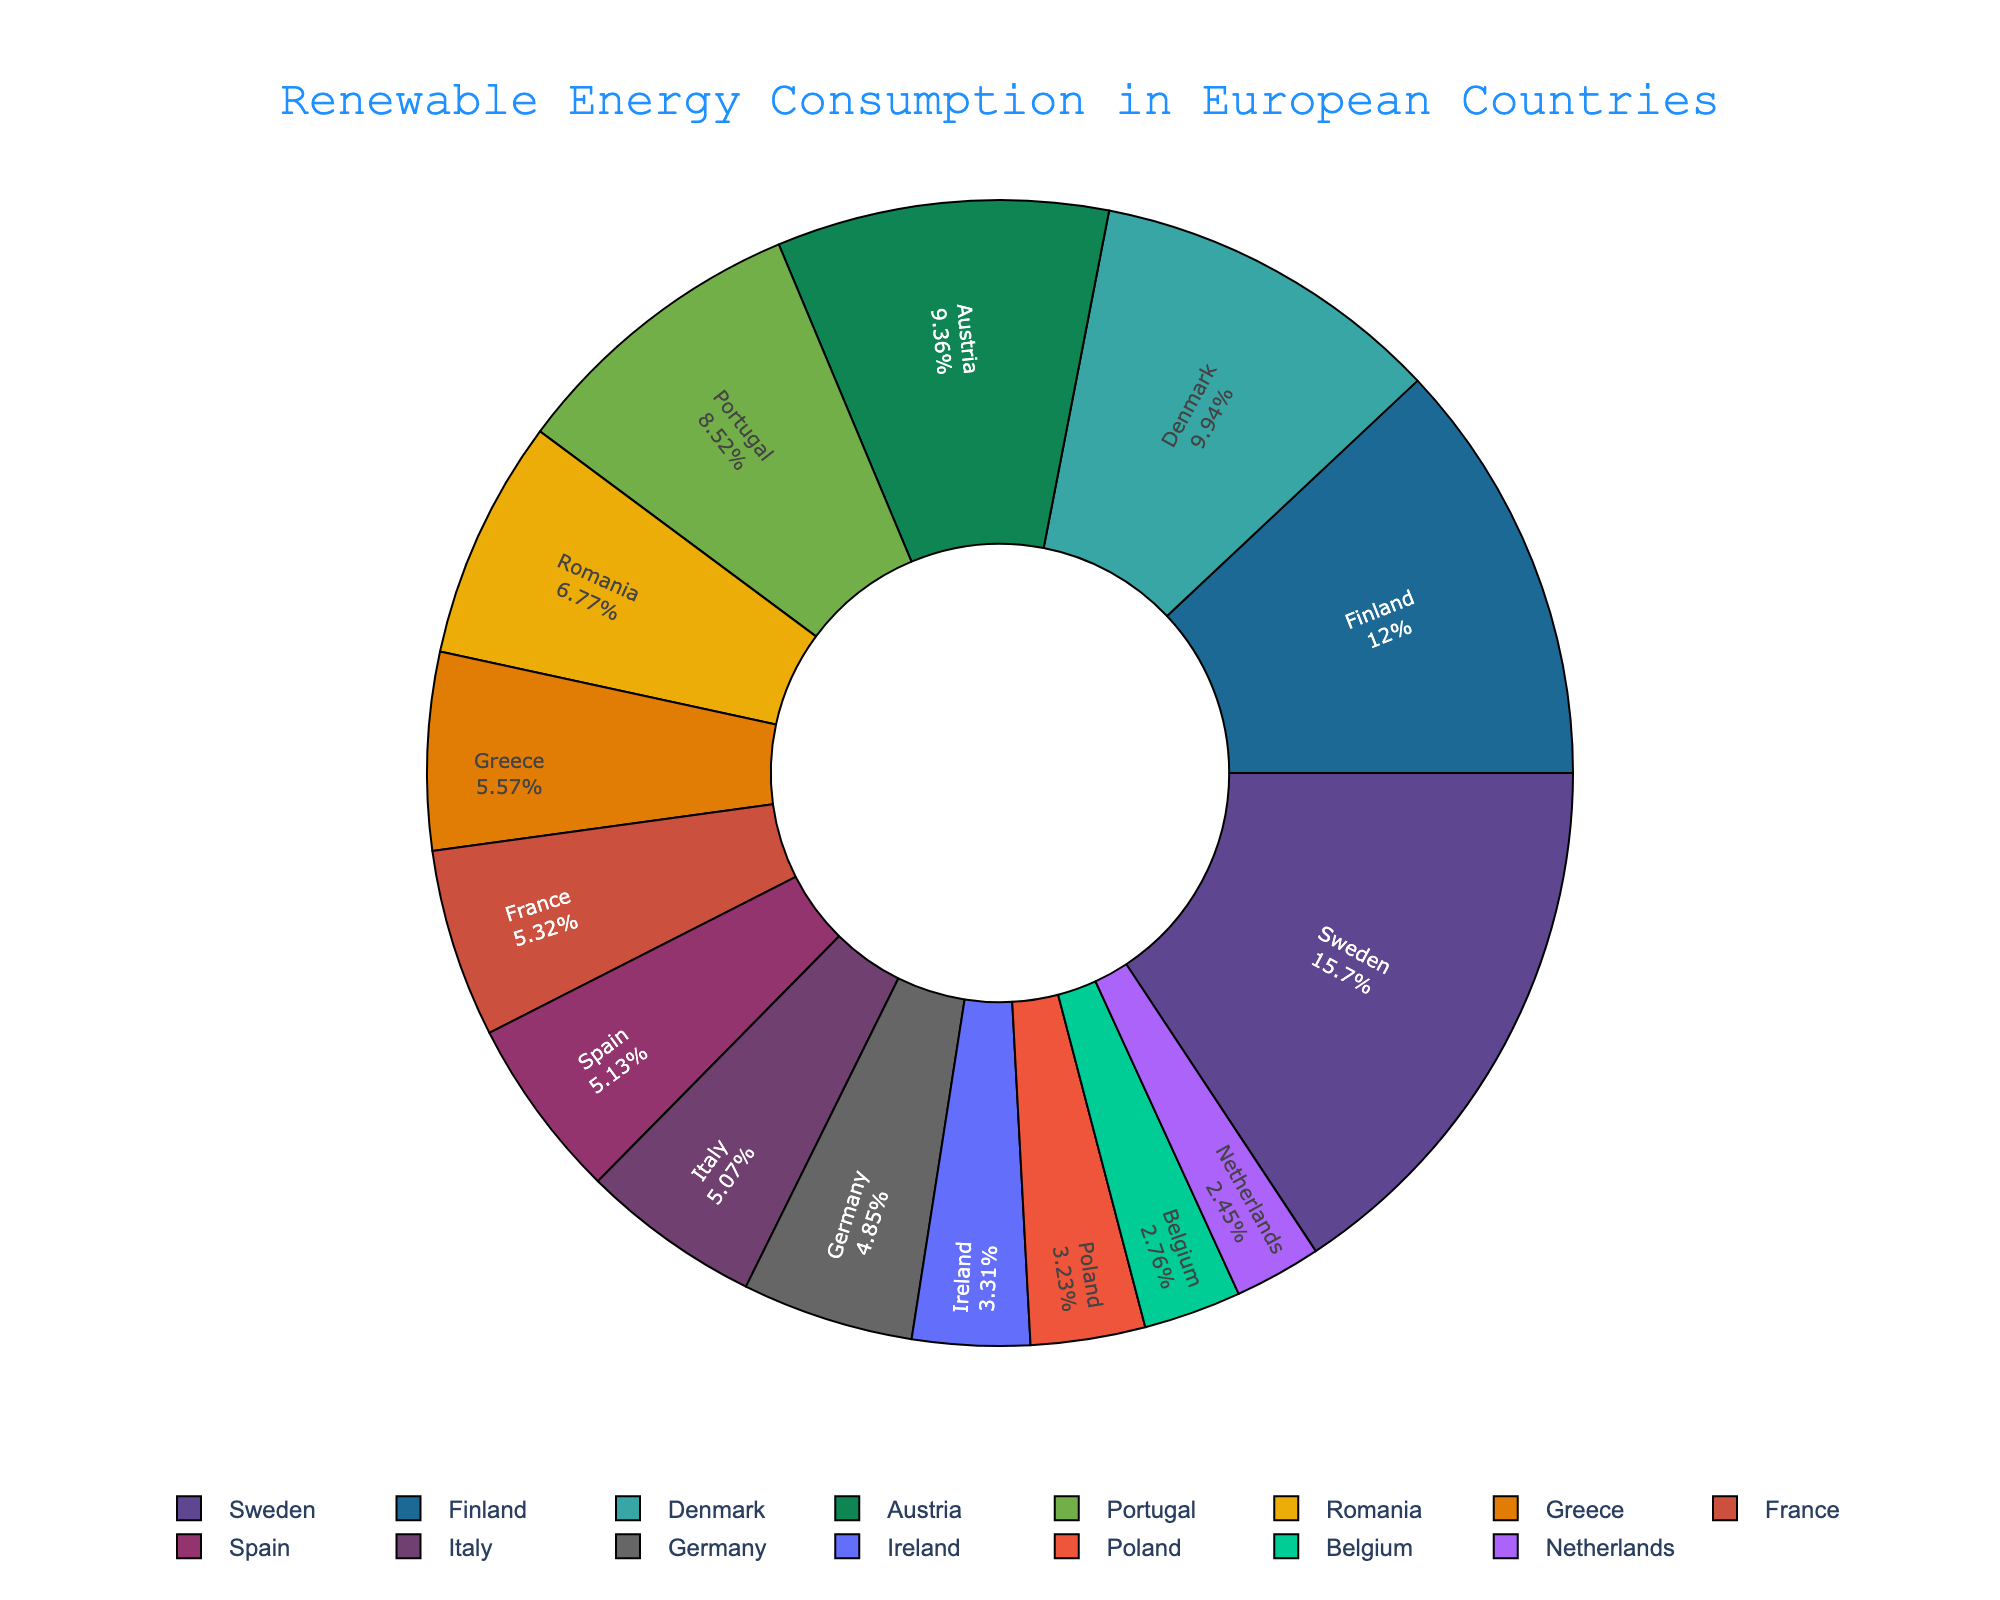What's the country with the highest proportion of renewable energy consumption? The pie chart shows that Sweden has the highest percentage of renewable energy consumption among the countries listed.
Answer: Sweden Which country has a higher renewable energy consumption proportion, Germany or Finland? The pie chart shows that Germany has a proportion of 17.4%, while Finland has a higher proportion of 43.1%.
Answer: Finland How much greater is Denmark's renewable energy proportion compared to Ireland's? Denmark's percentage is 35.7%, and Ireland's is 11.9%. The difference is calculated as 35.7 - 11.9 = 23.8%.
Answer: 23.8% What is the combined percentage of renewable energy consumption for Italy, Spain, and Greece? Italy (18.2%), Spain (18.4%), and Greece (20.0%) have a combined percentage of 18.2 + 18.4 + 20.0 = 56.6%.
Answer: 56.6% Which country has the lowest proportion of renewable energy consumption? The pie chart shows that the Netherlands has the lowest percentage, which is 8.8%.
Answer: Netherlands Among the countries listed, how many have a renewable energy proportion higher than 30%? The countries with proportions higher than 30% are Sweden (56.4%), Finland (43.1%), Denmark (35.7%), and Portugal (30.6%). Therefore, there are 4 countries.
Answer: 4 What is the average proportion of renewable energy consumption for France, Belgium, and Romania? The percentages are France (19.1%), Belgium (9.9%), and Romania (24.3%). The average is (19.1 + 9.9 + 24.3)/3 = 17.77%.
Answer: 17.77% How many countries have a renewable energy consumption proportion below 15%? The countries below 15% are Germany (17.4%), Netherlands (8.8%), Belgium (9.9%), Ireland (11.9%), and Poland (11.6%). None of these satisfy the condition except the Netherlands, Belgium, Ireland, and Poland, making 4 countries.
Answer: 4 Is Austria's renewable energy proportion more than double that of Poland? Austria's percentage is 33.6% and Poland's is 11.6%. Double of Poland's is 11.6 * 2 = 23.2%. Austria's 33.6% is indeed more than double of Poland's 23.2%.
Answer: Yes 